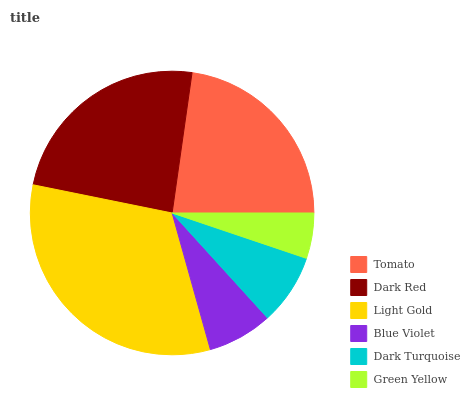Is Green Yellow the minimum?
Answer yes or no. Yes. Is Light Gold the maximum?
Answer yes or no. Yes. Is Dark Red the minimum?
Answer yes or no. No. Is Dark Red the maximum?
Answer yes or no. No. Is Dark Red greater than Tomato?
Answer yes or no. Yes. Is Tomato less than Dark Red?
Answer yes or no. Yes. Is Tomato greater than Dark Red?
Answer yes or no. No. Is Dark Red less than Tomato?
Answer yes or no. No. Is Tomato the high median?
Answer yes or no. Yes. Is Dark Turquoise the low median?
Answer yes or no. Yes. Is Blue Violet the high median?
Answer yes or no. No. Is Tomato the low median?
Answer yes or no. No. 